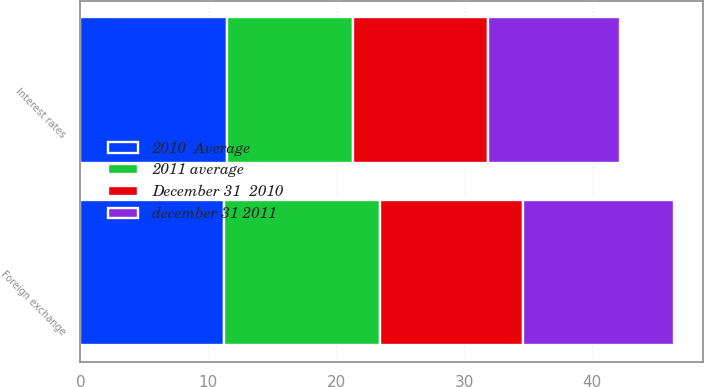Convert chart to OTSL. <chart><loc_0><loc_0><loc_500><loc_500><stacked_bar_chart><ecel><fcel>Interest rates<fcel>Foreign exchange<nl><fcel>december 31 2011<fcel>10.3<fcel>11.8<nl><fcel>December 31  2010<fcel>10.6<fcel>11.2<nl><fcel>2011 average<fcel>9.8<fcel>12.2<nl><fcel>2010  Average<fcel>11.5<fcel>11.2<nl></chart> 